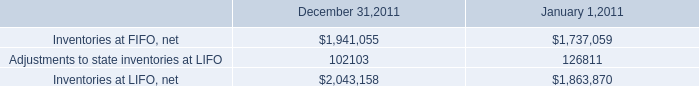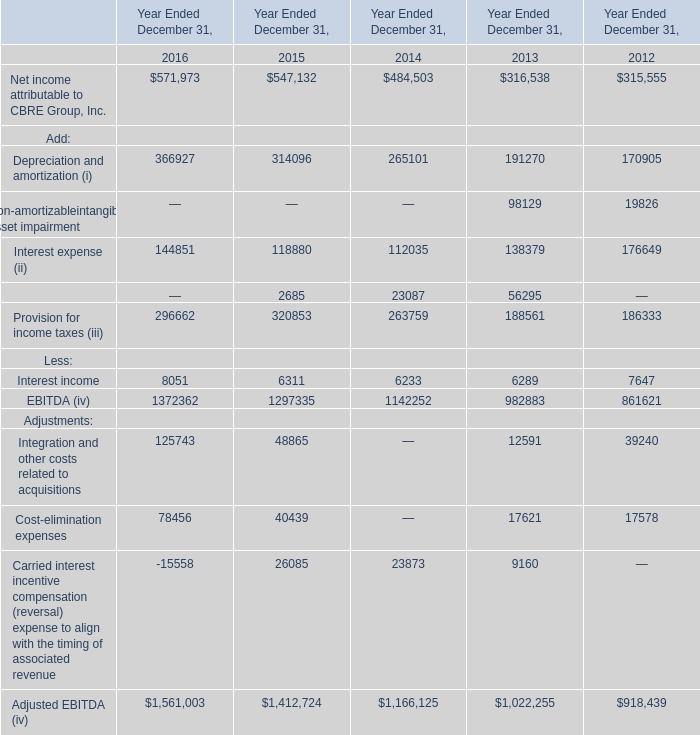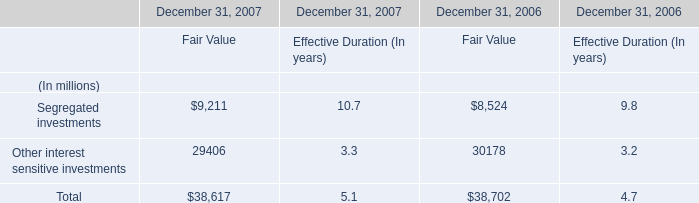What is the average value of Net income attributable to CBRE Group, Inc. in in 2016, 2015, and 2014 ? 
Computations: (((571973 + 547132) + 484503) / 3)
Answer: 534536.0. 